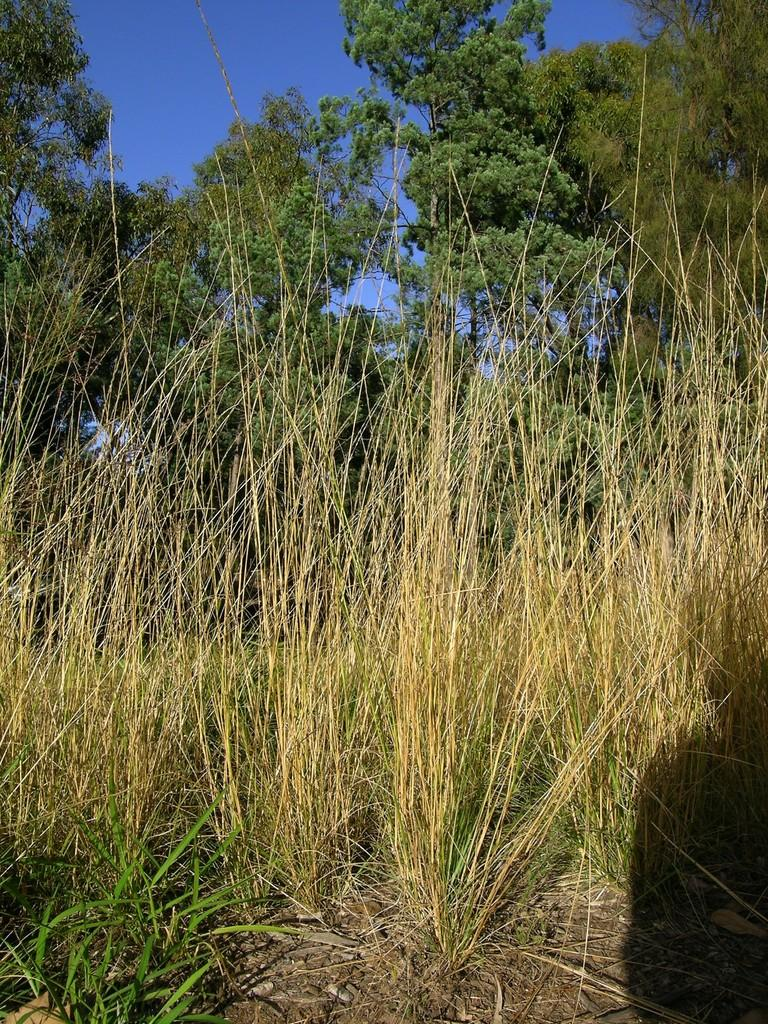What type of environment is depicted in the image? The image features greenery, suggesting a natural or outdoor setting. Can you describe any other elements in the image? There appears to be a shadow in the bottom right side of the image. What type of dress is hanging in the bedroom in the image? There is no bedroom or dress present in the image; it features greenery and a shadow. 